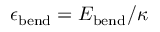Convert formula to latex. <formula><loc_0><loc_0><loc_500><loc_500>\epsilon _ { b e n d } = E _ { b e n d } / \kappa</formula> 